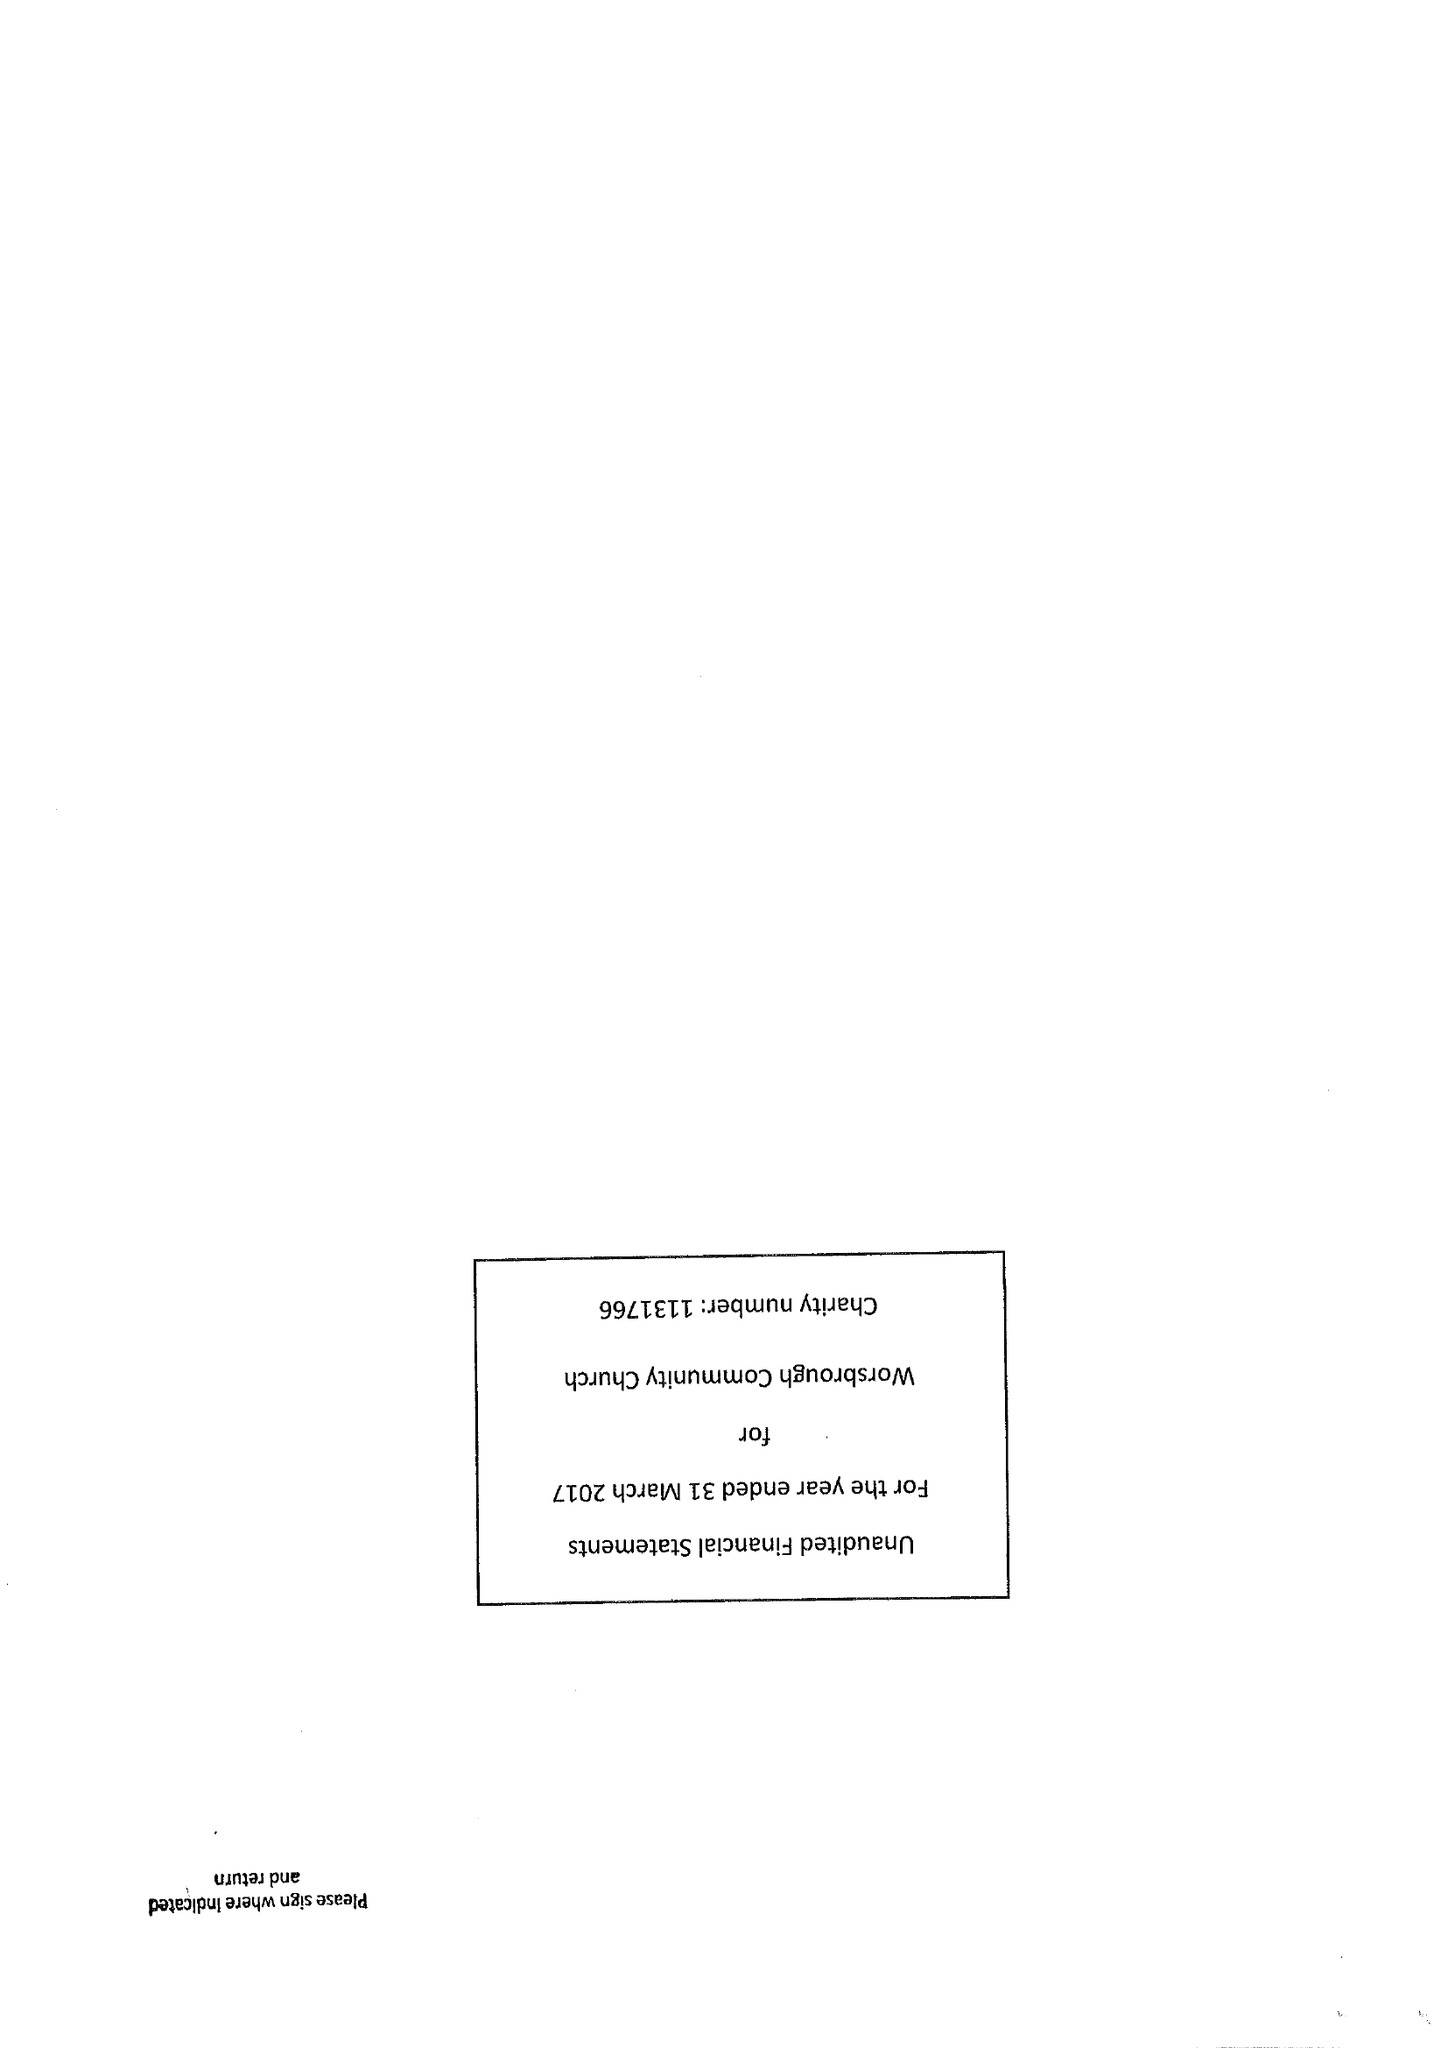What is the value for the spending_annually_in_british_pounds?
Answer the question using a single word or phrase. 22921.00 